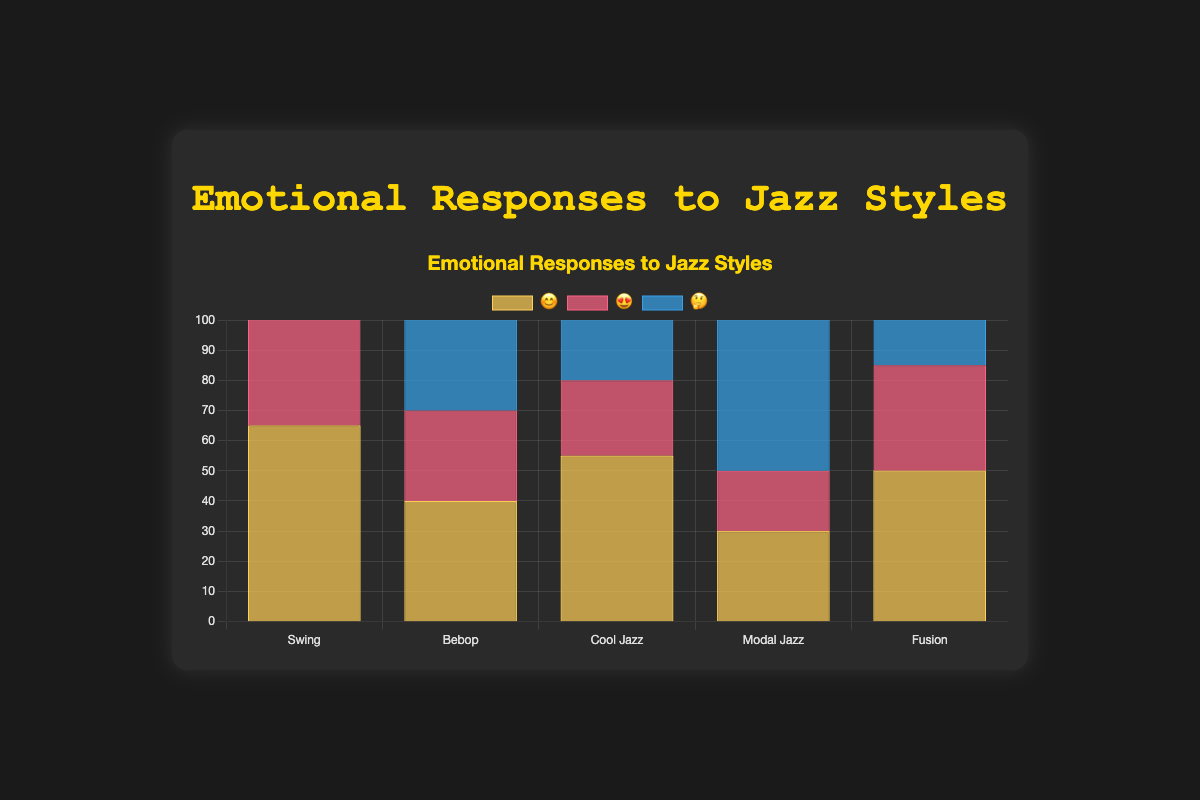What's the title of the figure? The title is located at the top of the figure and is usually displayed in bold text. It gives an overview of what the chart represents.
Answer: Emotional Responses to Jazz Styles How many jazz styles are represented in the chart? Count the distinct labels on the x-axis of the chart, each representing a different jazz style.
Answer: 5 Which jazz style has the highest number of 🤔 reactions? Review the height of the 🤔 (thinking face) bars across all jazz styles, and identify the one with the tallest bar.
Answer: Modal Jazz Which jazz style received the most overall positive reactions (😊 + 😍)? Sum the counts of 😊 and 😍 reactions for each style, then compare the totals. Swing has 65 + 45 = 110, Bebop has 40 + 30 = 70, Cool Jazz has 55 + 25 = 80, Modal Jazz has 30 + 20 = 50, and Fusion has 50 + 35 = 85.
Answer: Swing For which jazz style are 🤔 reactions more frequent than 😊 reactions? Compare the counts of 🤔 and 😊 reactions for each style. Bebop has 50 > 40 and Modal Jazz has 70 > 30.
Answer: Bebop, Modal Jazz What is the sum of all reactions for Cool Jazz? Add the counts of all types of reactions (😊, 😍, 🤔) for Cool Jazz.
Answer: 55 + 25 + 35 = 115 How do the 😍 reactions for Bebop compare to those for Swing? Check the height of the 😍 (heart eyes) bars for Bebop and Swing and note the difference. Swing has 45 😍 reactions while Bebop has 30.
Answer: Swing has 15 more 😍 reactions than Bebop Which jazz style received exactly 35 🤔 reactions? Check the height values of the 🤔 bars and identify the one that equals 35.
Answer: Cool Jazz What is the average number of 😊 reactions across all jazz styles? Sum the counts of 😊 reactions for all styles and divide by the number of styles. (65 + 40 + 55 + 30 + 50) / 5 = 240 / 5 = 48.
Answer: 48 Which jazz style has the least number of 😍 reactions? Compare the height of the 😍 (heart eyes) bars across all jazz styles to find the shortest one.
Answer: Modal Jazz 